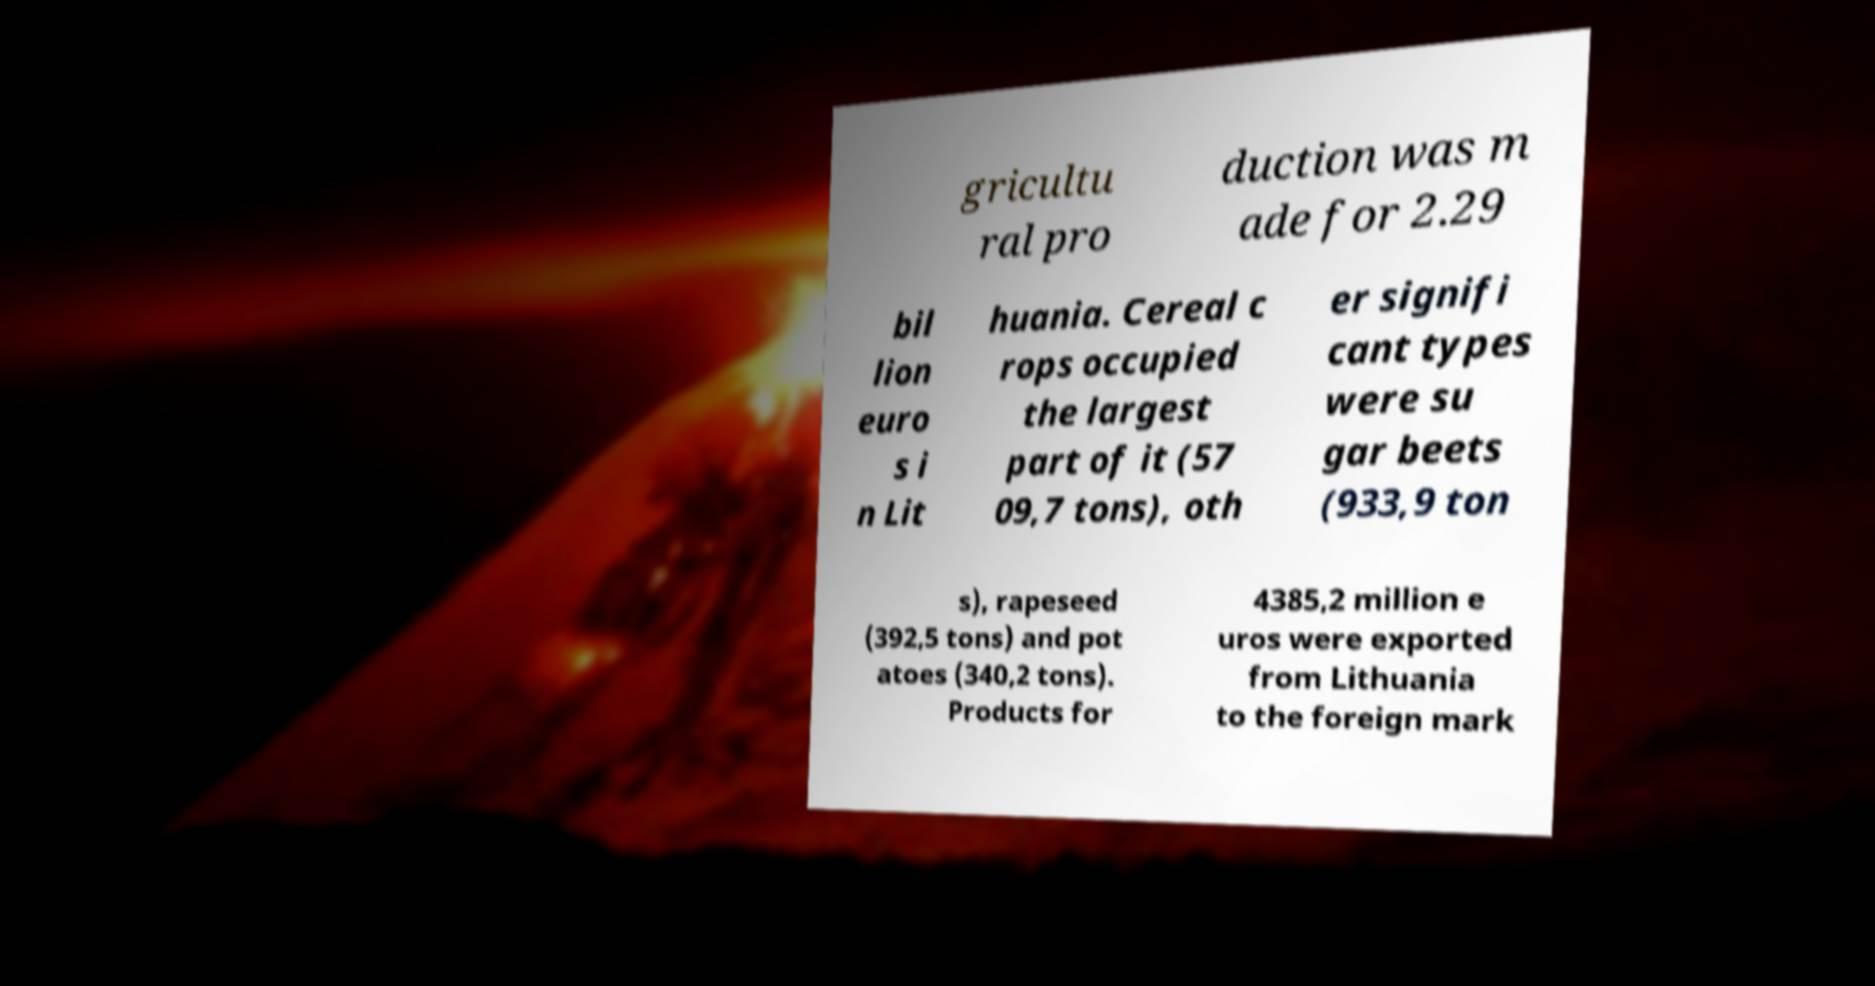Can you accurately transcribe the text from the provided image for me? gricultu ral pro duction was m ade for 2.29 bil lion euro s i n Lit huania. Cereal c rops occupied the largest part of it (57 09,7 tons), oth er signifi cant types were su gar beets (933,9 ton s), rapeseed (392,5 tons) and pot atoes (340,2 tons). Products for 4385,2 million e uros were exported from Lithuania to the foreign mark 